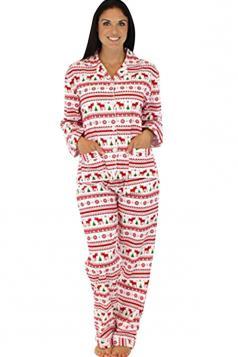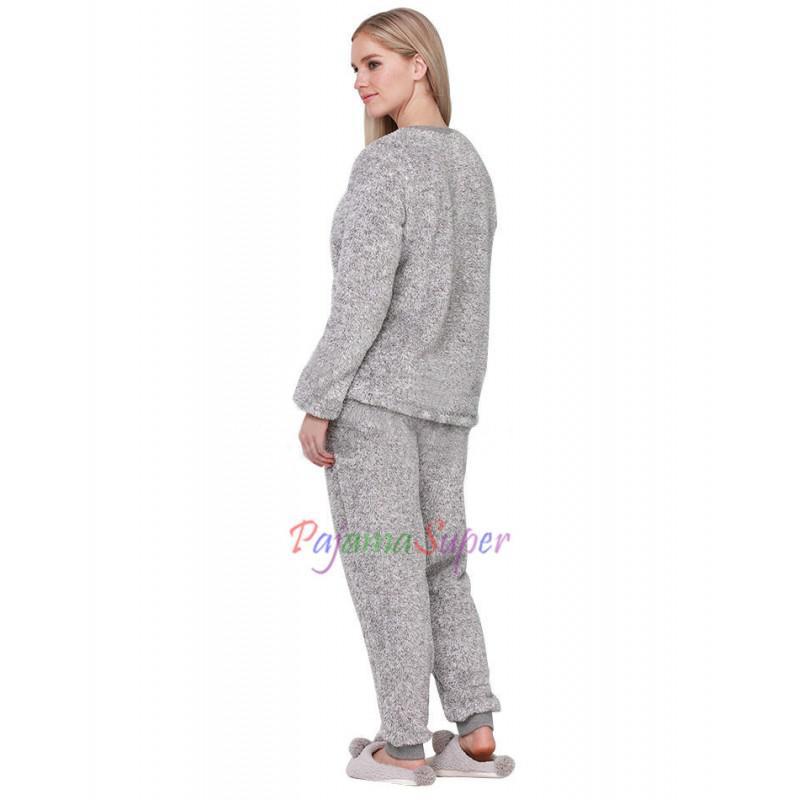The first image is the image on the left, the second image is the image on the right. Considering the images on both sides, is "All of the girls are brunettes." valid? Answer yes or no. No. The first image is the image on the left, the second image is the image on the right. Evaluate the accuracy of this statement regarding the images: "One pair of pajamas has red trim around the neck and the ankles.". Is it true? Answer yes or no. No. 